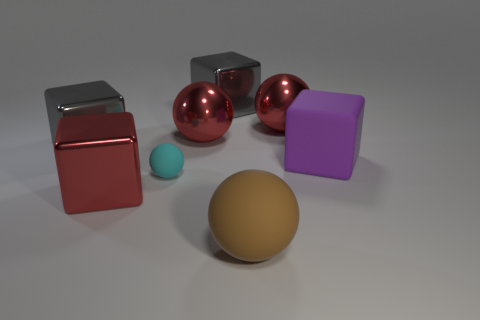Subtract 1 balls. How many balls are left? 3 Add 1 big blue matte balls. How many objects exist? 9 Subtract 0 cyan cylinders. How many objects are left? 8 Subtract all small red matte cubes. Subtract all big spheres. How many objects are left? 5 Add 2 red shiny blocks. How many red shiny blocks are left? 3 Add 3 metallic blocks. How many metallic blocks exist? 6 